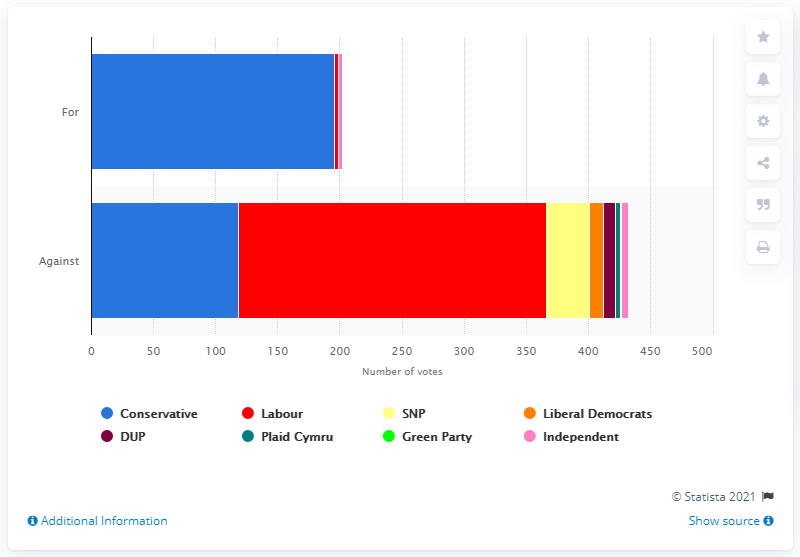Draw attention to some important aspects in this diagram. A total of 118 Conservative MPs rebelled against their leader. 